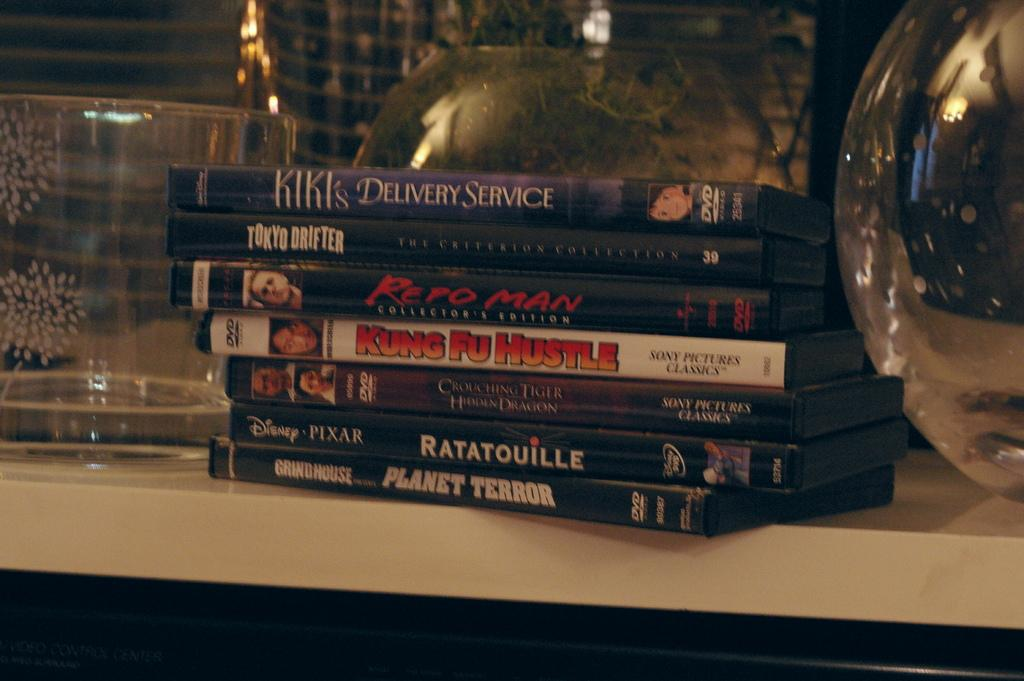<image>
Present a compact description of the photo's key features. A stack of DVDs including Ratatouille, King Fu Hustle and Repo Man. 